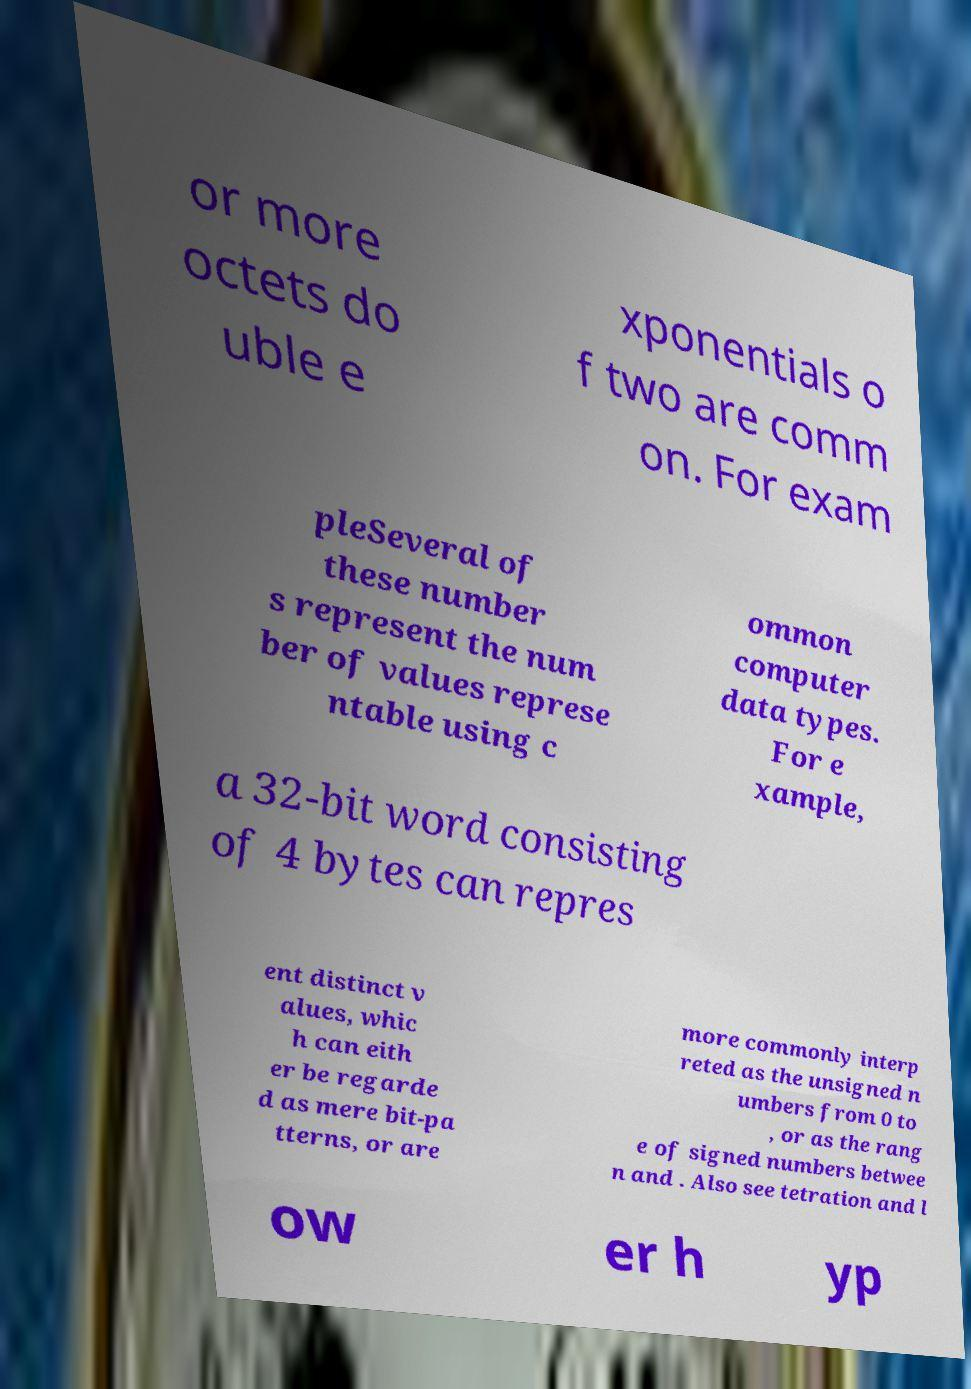Please identify and transcribe the text found in this image. or more octets do uble e xponentials o f two are comm on. For exam pleSeveral of these number s represent the num ber of values represe ntable using c ommon computer data types. For e xample, a 32-bit word consisting of 4 bytes can repres ent distinct v alues, whic h can eith er be regarde d as mere bit-pa tterns, or are more commonly interp reted as the unsigned n umbers from 0 to , or as the rang e of signed numbers betwee n and . Also see tetration and l ow er h yp 